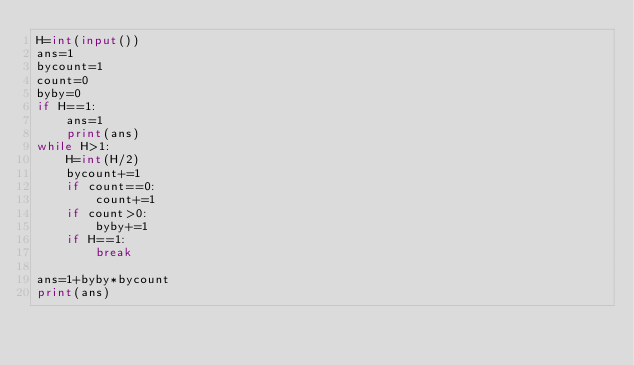Convert code to text. <code><loc_0><loc_0><loc_500><loc_500><_Python_>H=int(input())
ans=1
bycount=1
count=0
byby=0
if H==1:
    ans=1
    print(ans)
while H>1:
    H=int(H/2)
    bycount+=1
    if count==0:
        count+=1
    if count>0:
        byby+=1
    if H==1:
        break

ans=1+byby*bycount
print(ans)</code> 